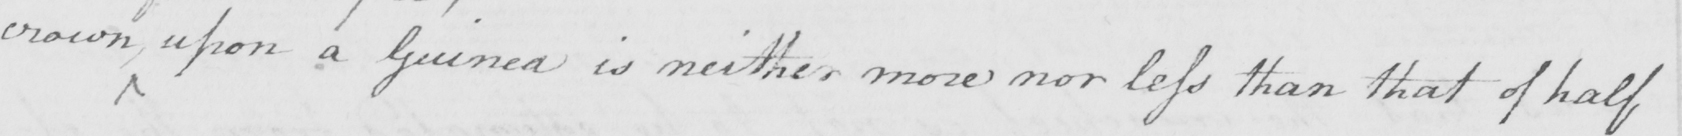Transcribe the text shown in this historical manuscript line. crown , upon a Guinea is neither more nor less than that of half 